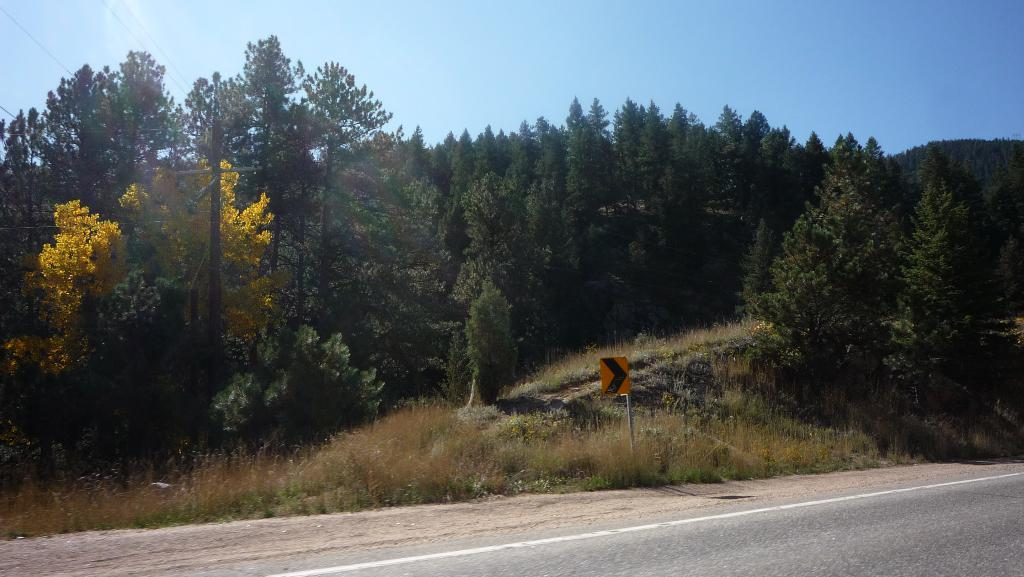What is located at the bottom of the image? There is a road at the bottom of the image. What can be seen in the middle of the image? Trees are visible in the middle of the image. What is in the background of the image? The sky is in the background of the image. What book is being read in the room depicted in the image? There is no room or book present in the image; it features a road, trees, and the sky. What thought is being expressed by the trees in the image? Trees do not express thoughts, and there are no thoughts depicted in the image. 